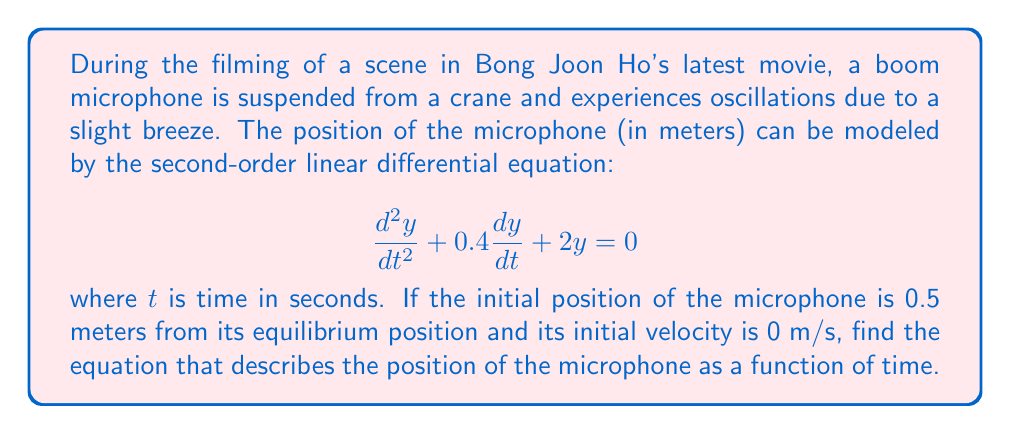Can you solve this math problem? To solve this problem, we'll follow these steps:

1) First, we need to determine the characteristic equation of the differential equation:
   $$r^2 + 0.4r + 2 = 0$$

2) Solve the characteristic equation:
   $$r = \frac{-0.4 \pm \sqrt{0.4^2 - 4(1)(2)}}{2(1)} = \frac{-0.4 \pm \sqrt{0.16 - 8}}{2} = \frac{-0.4 \pm \sqrt{-7.84}}{2}$$

3) This gives us complex roots:
   $$r = -0.2 \pm 1.4i$$

4) The general solution for this type of equation is:
   $$y(t) = e^{-0.2t}(A\cos(1.4t) + B\sin(1.4t))$$

5) Now we use the initial conditions to find A and B:
   At $t=0$, $y(0) = 0.5$ and $y'(0) = 0$

6) From $y(0) = 0.5$:
   $$0.5 = A$$

7) From $y'(0) = 0$:
   $$y'(t) = -0.2e^{-0.2t}(A\cos(1.4t) + B\sin(1.4t)) + e^{-0.2t}(-1.4A\sin(1.4t) + 1.4B\cos(1.4t))$$
   $$0 = -0.2A + 1.4B$$
   $$B = \frac{0.2A}{1.4} = \frac{0.2(0.5)}{1.4} = \frac{1}{14}$$

8) Therefore, the solution is:
   $$y(t) = e^{-0.2t}(0.5\cos(1.4t) + \frac{1}{14}\sin(1.4t))$$
Answer: $$y(t) = e^{-0.2t}(0.5\cos(1.4t) + \frac{1}{14}\sin(1.4t))$$ 